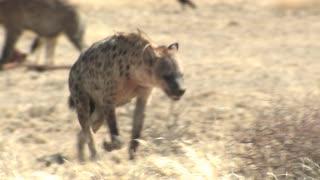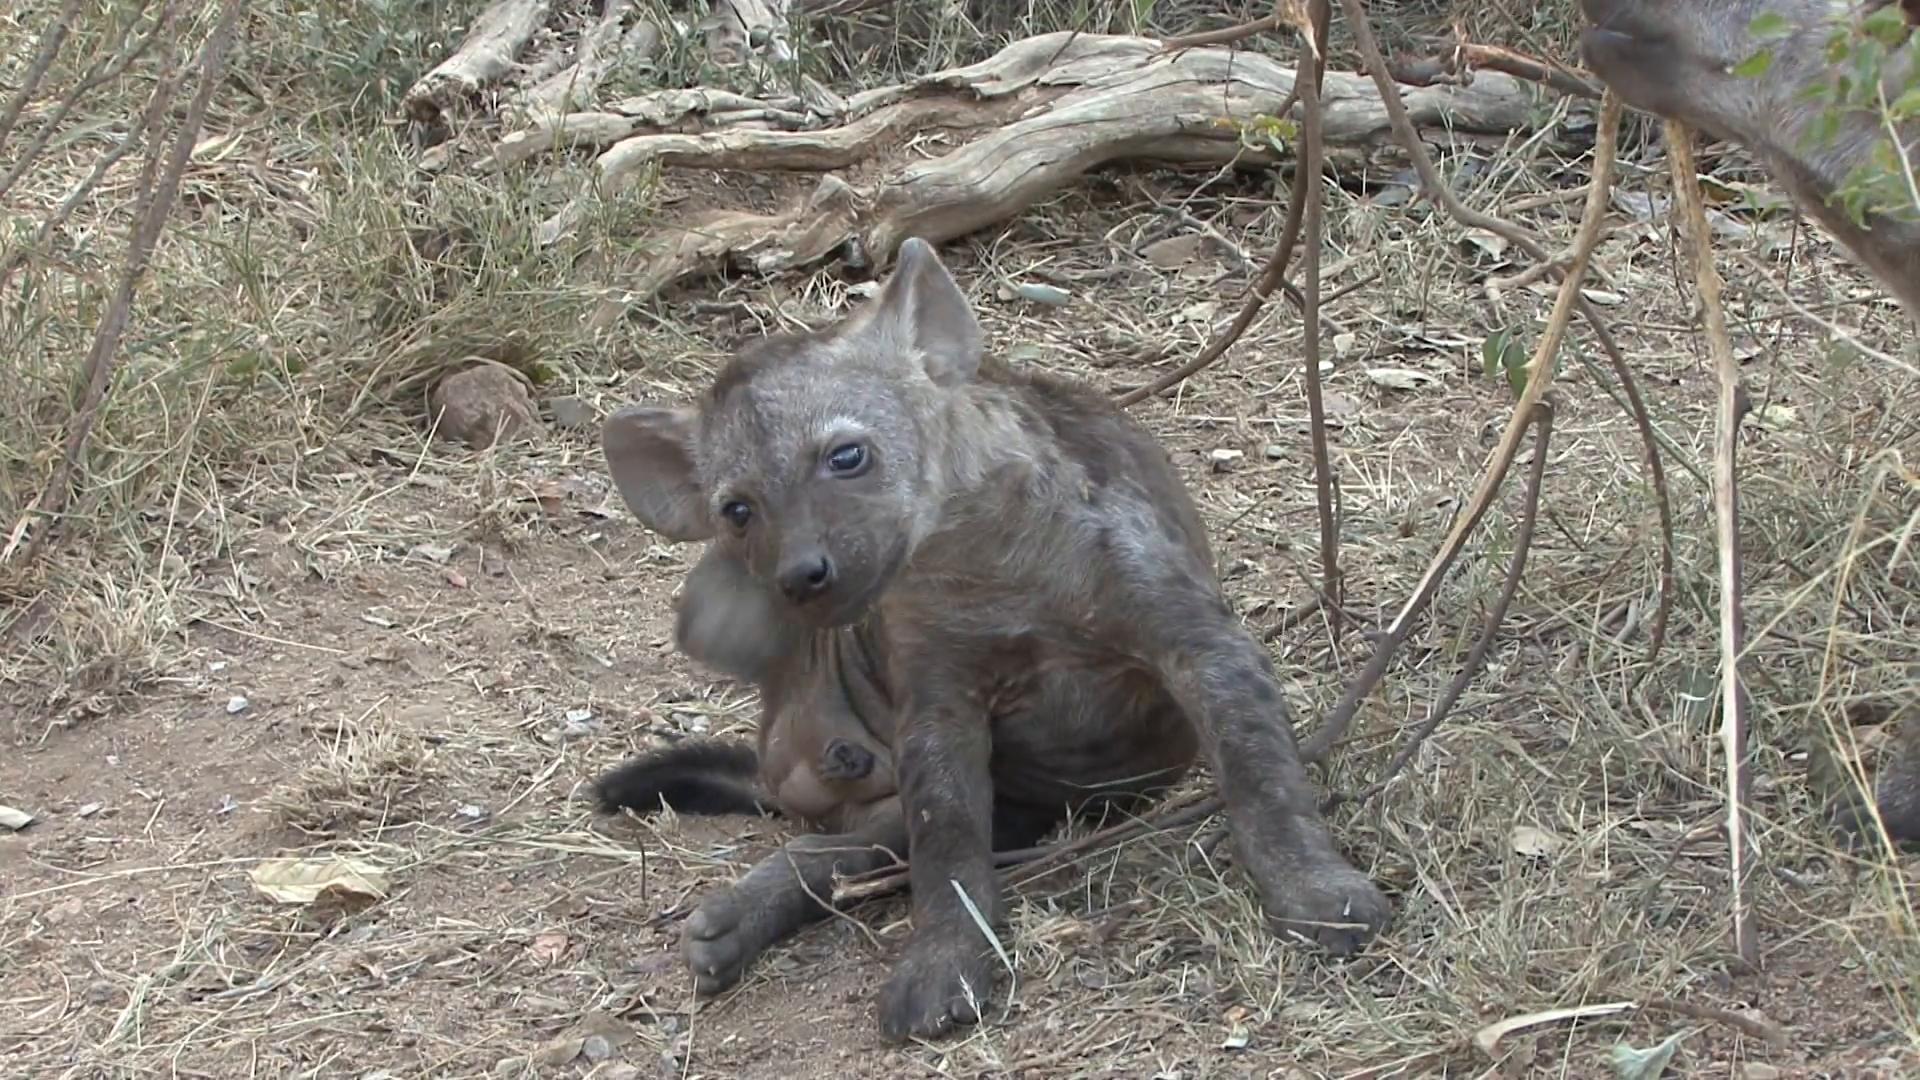The first image is the image on the left, the second image is the image on the right. Analyze the images presented: Is the assertion "There are two hyenas in the right image." valid? Answer yes or no. No. The first image is the image on the left, the second image is the image on the right. For the images displayed, is the sentence "The hyena in the foreground of the left image is walking forward at a rightward angle with its head lowered and one front paw off the ground and bent inward." factually correct? Answer yes or no. Yes. 